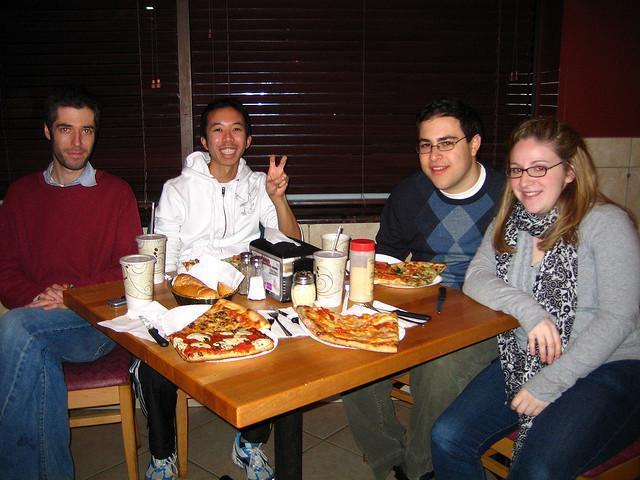How many fingers is the male in white holding up?
Give a very brief answer. 2. How many people are seated?
Give a very brief answer. 4. How many people are in the photo?
Give a very brief answer. 4. How many people are wearing plaid shirts?
Give a very brief answer. 0. How many people are sitting?
Give a very brief answer. 4. How many pizzas are visible?
Give a very brief answer. 2. How many people can you see?
Give a very brief answer. 4. How many trains are on the tracks?
Give a very brief answer. 0. 